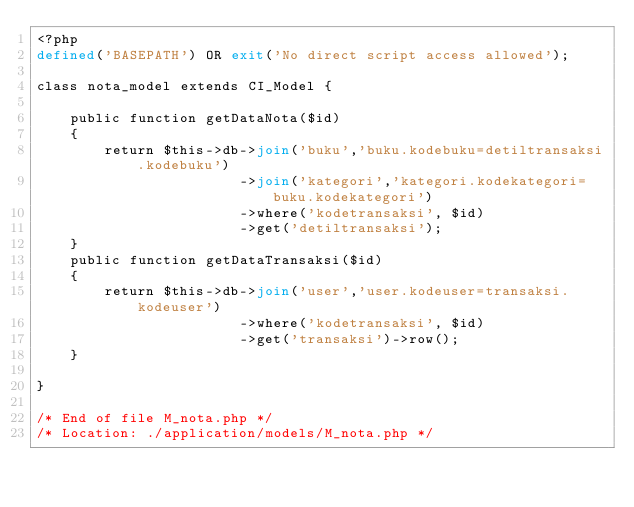<code> <loc_0><loc_0><loc_500><loc_500><_PHP_><?php
defined('BASEPATH') OR exit('No direct script access allowed');

class nota_model extends CI_Model {

	public function getDataNota($id)
	{
		return $this->db->join('buku','buku.kodebuku=detiltransaksi.kodebuku')
						->join('kategori','kategori.kodekategori=buku.kodekategori')
						->where('kodetransaksi', $id)
						->get('detiltransaksi');
	}
	public function getDataTransaksi($id)
	{
		return $this->db->join('user','user.kodeuser=transaksi.kodeuser')
						->where('kodetransaksi', $id)
						->get('transaksi')->row();
	}

}

/* End of file M_nota.php */
/* Location: ./application/models/M_nota.php */</code> 